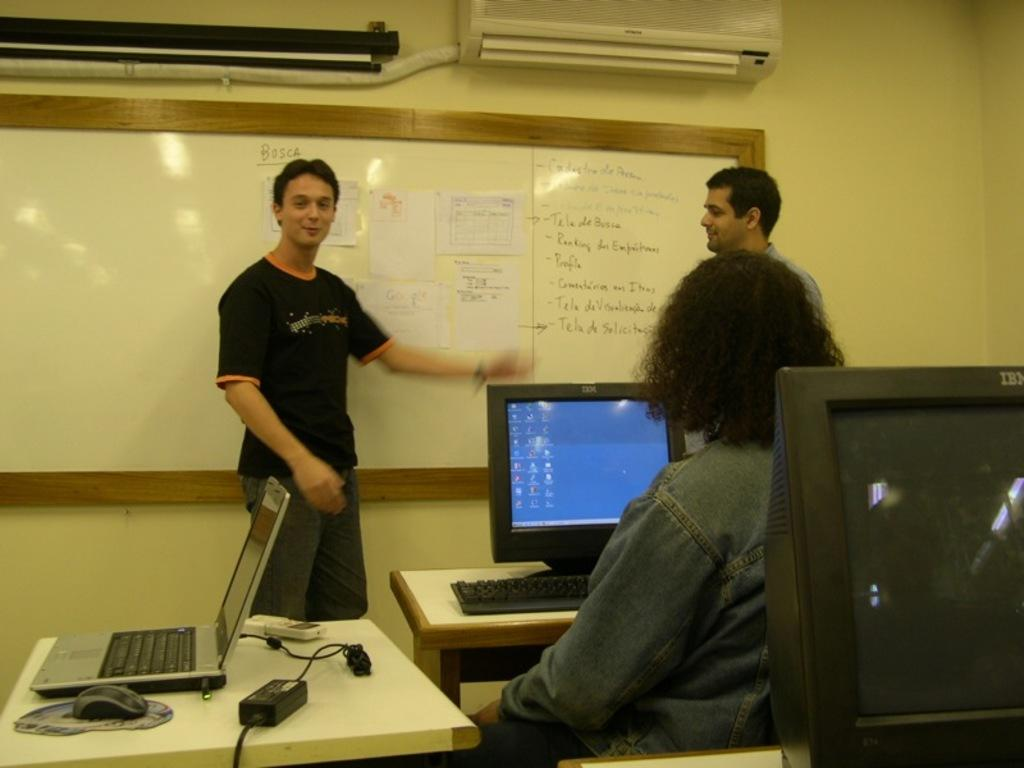What color is the wall in the image? The wall in the image is yellow. What appliance can be seen in the image? There is an air conditioner in the image. What type of board is present in the image? There is a white color board in the image. How many people are in the image? There are three people in the image. What type of furniture is visible in the image? There are tables in the image. What device is used for displaying information in the image? There is a screen in the image. What type of planes are flying in the image? There are no planes visible in the image. What is the name of the daughter in the image? There is no mention of a daughter or any individuals' names in the image. 